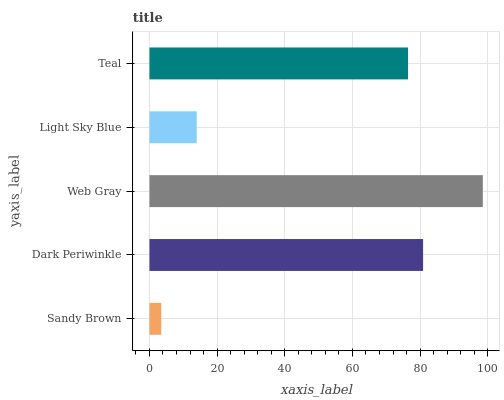Is Sandy Brown the minimum?
Answer yes or no. Yes. Is Web Gray the maximum?
Answer yes or no. Yes. Is Dark Periwinkle the minimum?
Answer yes or no. No. Is Dark Periwinkle the maximum?
Answer yes or no. No. Is Dark Periwinkle greater than Sandy Brown?
Answer yes or no. Yes. Is Sandy Brown less than Dark Periwinkle?
Answer yes or no. Yes. Is Sandy Brown greater than Dark Periwinkle?
Answer yes or no. No. Is Dark Periwinkle less than Sandy Brown?
Answer yes or no. No. Is Teal the high median?
Answer yes or no. Yes. Is Teal the low median?
Answer yes or no. Yes. Is Dark Periwinkle the high median?
Answer yes or no. No. Is Web Gray the low median?
Answer yes or no. No. 